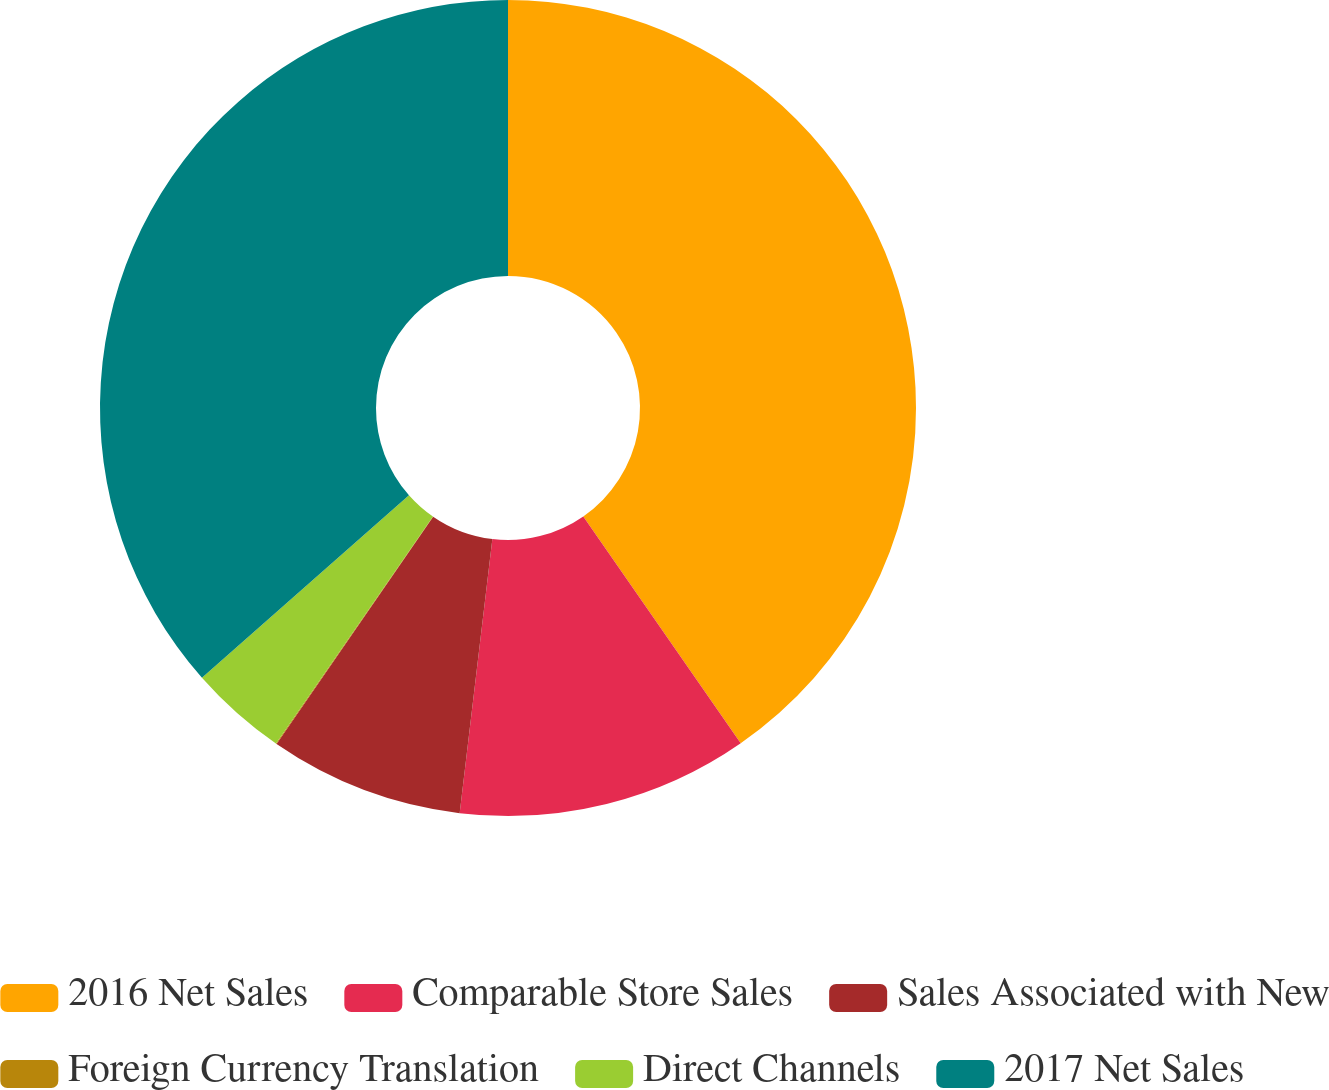Convert chart to OTSL. <chart><loc_0><loc_0><loc_500><loc_500><pie_chart><fcel>2016 Net Sales<fcel>Comparable Store Sales<fcel>Sales Associated with New<fcel>Foreign Currency Translation<fcel>Direct Channels<fcel>2017 Net Sales<nl><fcel>40.34%<fcel>11.55%<fcel>7.71%<fcel>0.03%<fcel>3.87%<fcel>36.5%<nl></chart> 